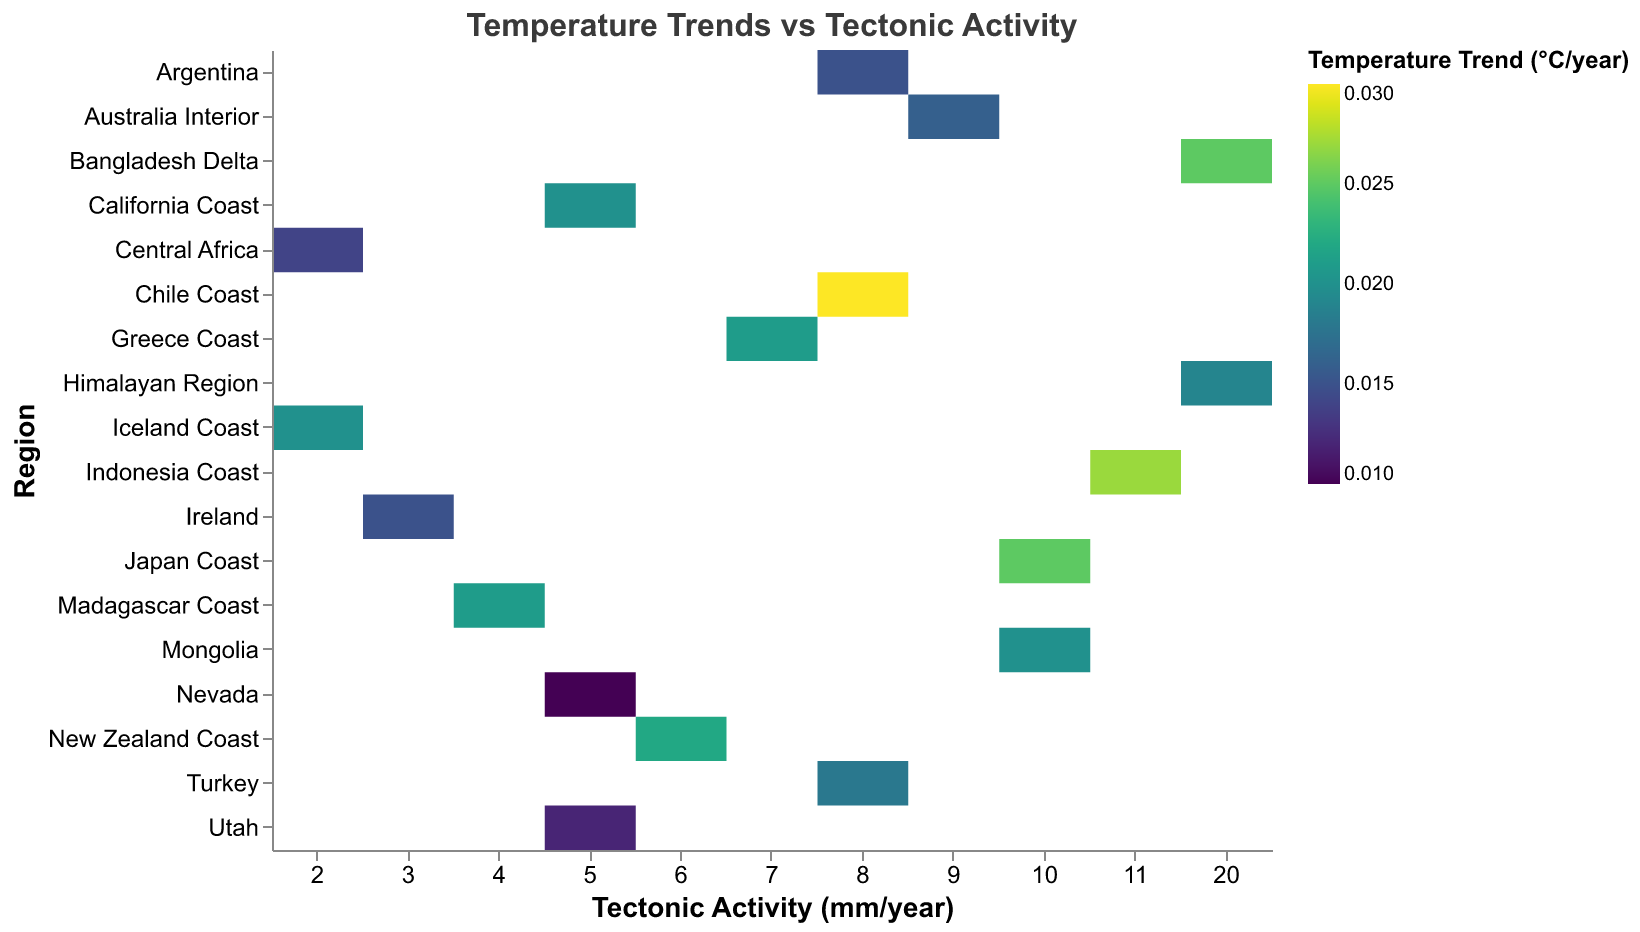What is the title of the heatmap? The title is displayed at the top of the heatmap and it is: "Temperature Trends vs Tectonic Activity".
Answer: Temperature Trends vs Tectonic Activity What are the labels on the x and y axes? The x-axis is labeled "Tectonic Activity (mm/year)" and the y-axis is labeled "Region".
Answer: Tectonic Activity (mm/year) and Region Which region has the highest tectonic activity and what is its corresponding temperature trend? By looking at the locations on the y-axis in descending order of activity, the highest tectonic activity is 20 mm/year, associated with the Himalayan Region and the Bangladesh Delta; their corresponding temperature trends are 0.019 °C/year and 0.025 °C/year, respectively.
Answer: Bangladesh Delta, 0.025 °C/year; Himalayan Region, 0.019 °C/year Which inland region has the highest temperature trend and what is the value? By finding the inland rows with the highest color intensity (based on the color legend), the inland region with the highest temperature trend is Mongolia, with a value of 0.02 °C/year.
Answer: Mongolia, 0.02 °C/year What is the average temperature trend for coastal regions with tectonic activity greater than 5 mm/year? First, identify coastal regions with tectonic activity greater than 5 mm/year: Chile Coast (0.03 °C/year), Japan Coast (0.025 °C/year), Greece Coast (0.021 °C/year), Indonesia Coast (0.027 °C/year), Bangladesh Delta (0.025 °C/year). Sum these temperature trends and divide by the count: (0.03 + 0.025 + 0.021 + 0.027 + 0.025) / 5 = 0.0256 °C/year.
Answer: 0.0256 °C/year Compare the temperature trends of inland regions on the North American Plate. Which region has a higher temperature trend? The inland regions on the North American Plate are Nevada (0.01 °C/year) and Utah (0.012 °C/year). By comparing these values, Utah has a higher temperature trend.
Answer: Utah How many data points have a tectonic activity of 8 mm/year and what are their locations? Identify the regions with tectonic activity of 8 mm/year: Chile Coast (coastal), Argentina (inland), and Turkey (inland). Count these regions: There are 3 data points.
Answer: 3 data points; Chile Coast, Argentina, Turkey Which has a higher temperature trend: the coastal region of California Coast or the inland region of Nevada? Compare California Coast’s temperature trend (0.02 °C/year) with Nevada’s temperature trend (0.01 °C/year), California Coast has a higher trend.
Answer: California Coast Among regions on the Indo-Australian Plate, which coastal region has the highest temperature trend? Identify the coastal regions on the Indo-Australian Plate: Indonesia Coast (0.027 °C/year). Since there's only one coastal region listed, Indonesia Coast has the highest trend.
Answer: Indonesia Coast, 0.027 °C/year 